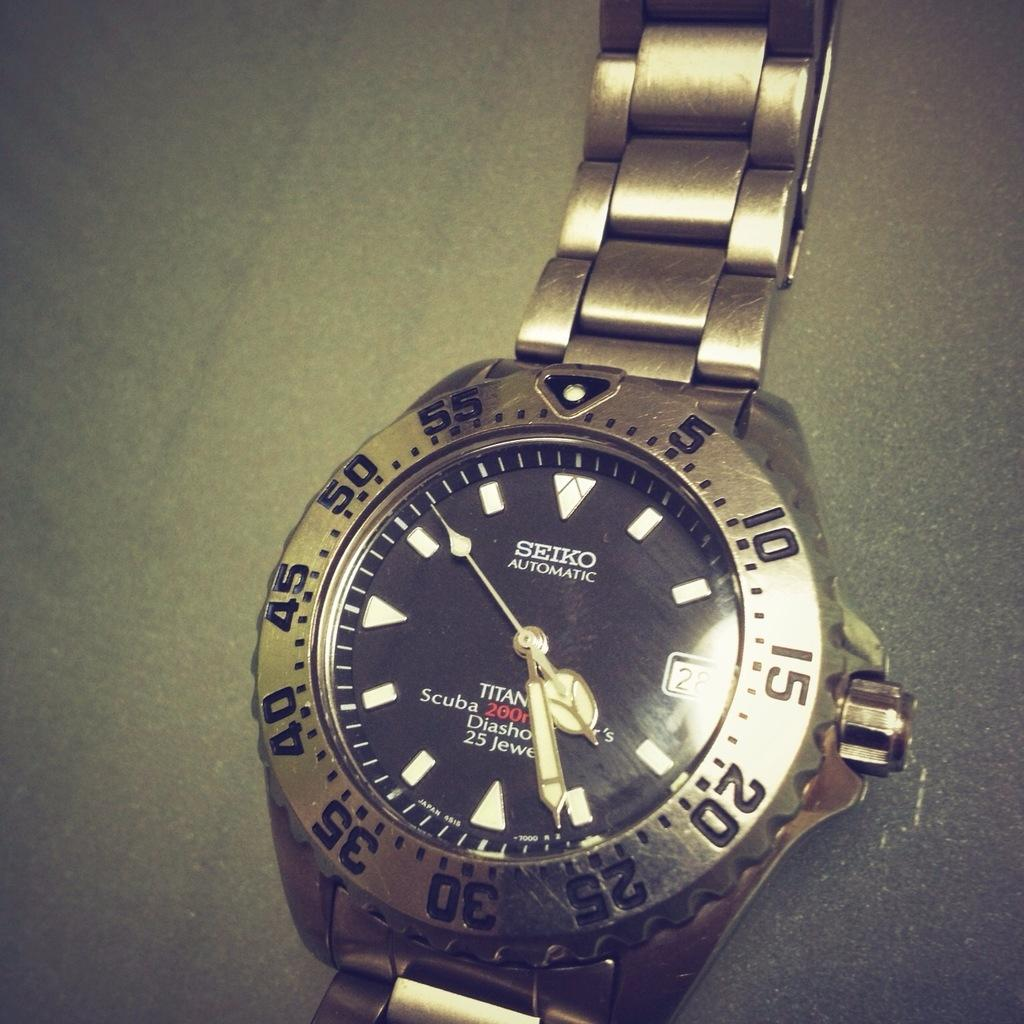<image>
Share a concise interpretation of the image provided. A Seiko automatic watch has a black face and gold watch band. 